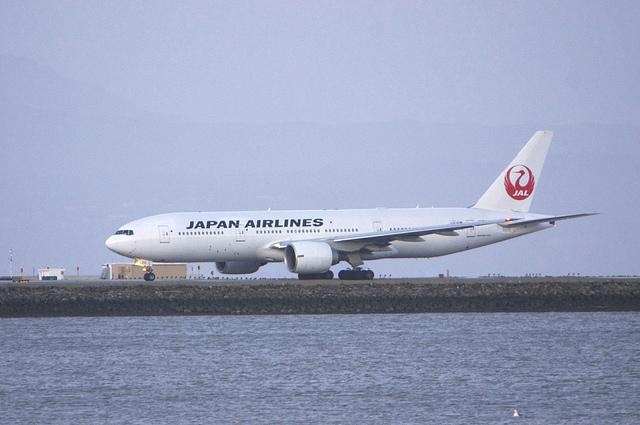Does this airline probably provide flights to Tokyo?
Give a very brief answer. Yes. What kind of animal is in the logo on the tail?
Be succinct. Duck. What country does this plane hail from?
Concise answer only. Japan. What airline is this plane from?
Keep it brief. Japan airlines. 